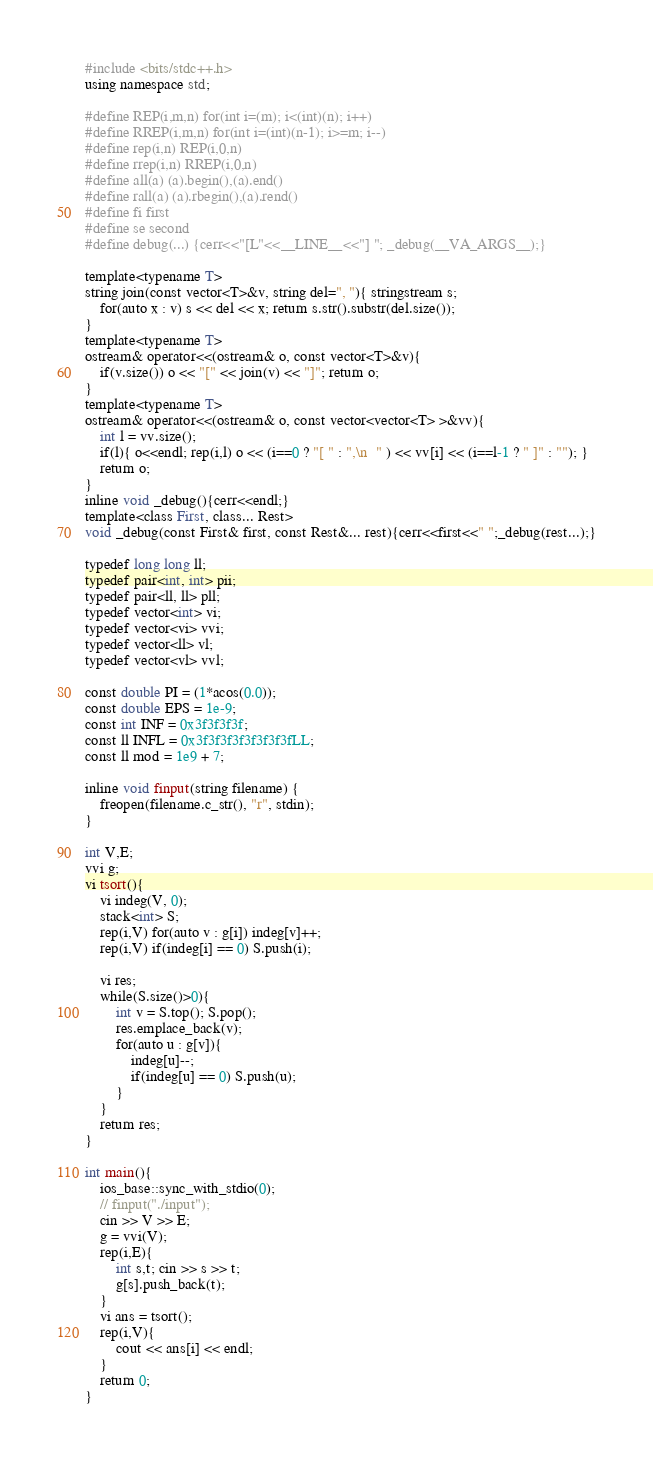Convert code to text. <code><loc_0><loc_0><loc_500><loc_500><_C++_>#include <bits/stdc++.h>
using namespace std;

#define REP(i,m,n) for(int i=(m); i<(int)(n); i++)
#define RREP(i,m,n) for(int i=(int)(n-1); i>=m; i--)
#define rep(i,n) REP(i,0,n)
#define rrep(i,n) RREP(i,0,n)
#define all(a) (a).begin(),(a).end()
#define rall(a) (a).rbegin(),(a).rend()
#define fi first
#define se second
#define debug(...) {cerr<<"[L"<<__LINE__<<"] "; _debug(__VA_ARGS__);}

template<typename T>
string join(const vector<T>&v, string del=", "){ stringstream s;
    for(auto x : v) s << del << x; return s.str().substr(del.size());
}
template<typename T>
ostream& operator<<(ostream& o, const vector<T>&v){
    if(v.size()) o << "[" << join(v) << "]"; return o;
}
template<typename T>
ostream& operator<<(ostream& o, const vector<vector<T> >&vv){
    int l = vv.size();
    if(l){ o<<endl; rep(i,l) o << (i==0 ? "[ " : ",\n  " ) << vv[i] << (i==l-1 ? " ]" : ""); }
    return o;
}
inline void _debug(){cerr<<endl;}
template<class First, class... Rest>
void _debug(const First& first, const Rest&... rest){cerr<<first<<" ";_debug(rest...);}

typedef long long ll;
typedef pair<int, int> pii;
typedef pair<ll, ll> pll;
typedef vector<int> vi;
typedef vector<vi> vvi;
typedef vector<ll> vl;
typedef vector<vl> vvl;

const double PI = (1*acos(0.0));
const double EPS = 1e-9;
const int INF = 0x3f3f3f3f;
const ll INFL = 0x3f3f3f3f3f3f3f3fLL;
const ll mod = 1e9 + 7;

inline void finput(string filename) {
    freopen(filename.c_str(), "r", stdin);
}

int V,E;
vvi g;
vi tsort(){
    vi indeg(V, 0);
    stack<int> S;
    rep(i,V) for(auto v : g[i]) indeg[v]++;
    rep(i,V) if(indeg[i] == 0) S.push(i);

    vi res;
    while(S.size()>0){
        int v = S.top(); S.pop();
        res.emplace_back(v);
        for(auto u : g[v]){
            indeg[u]--;
            if(indeg[u] == 0) S.push(u);
        }
    }
    return res;
}

int main(){
    ios_base::sync_with_stdio(0);
    // finput("./input");
    cin >> V >> E;
    g = vvi(V);
    rep(i,E){
        int s,t; cin >> s >> t;
        g[s].push_back(t);
    }
    vi ans = tsort();
    rep(i,V){
        cout << ans[i] << endl;
    }
    return 0;
}
</code> 